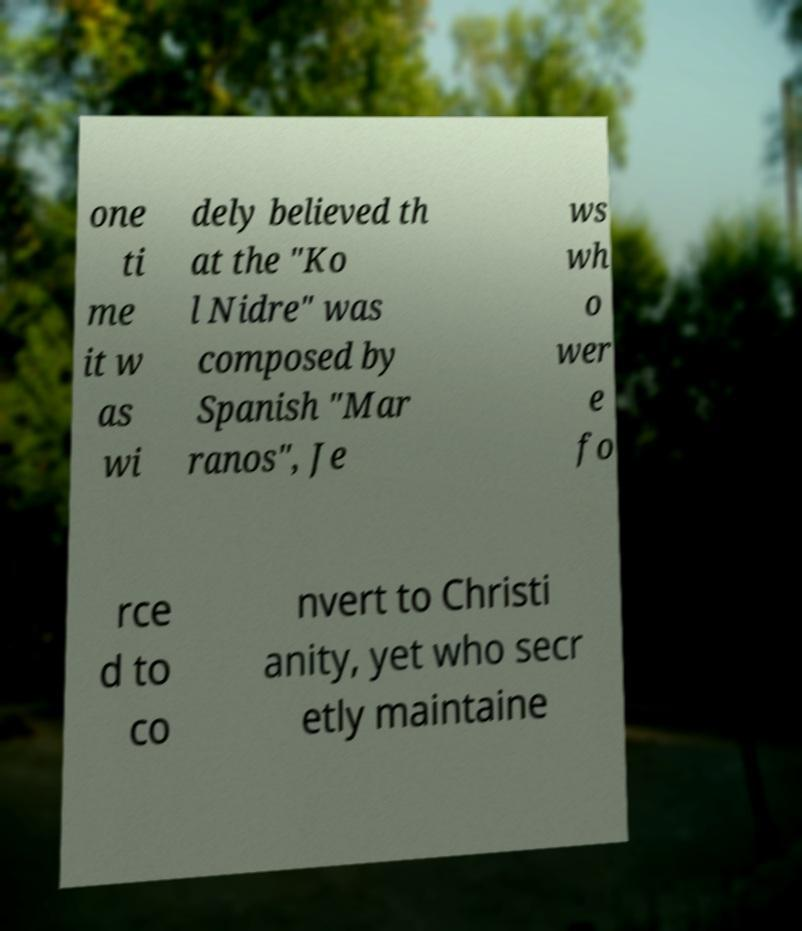Could you assist in decoding the text presented in this image and type it out clearly? one ti me it w as wi dely believed th at the "Ko l Nidre" was composed by Spanish "Mar ranos", Je ws wh o wer e fo rce d to co nvert to Christi anity, yet who secr etly maintaine 